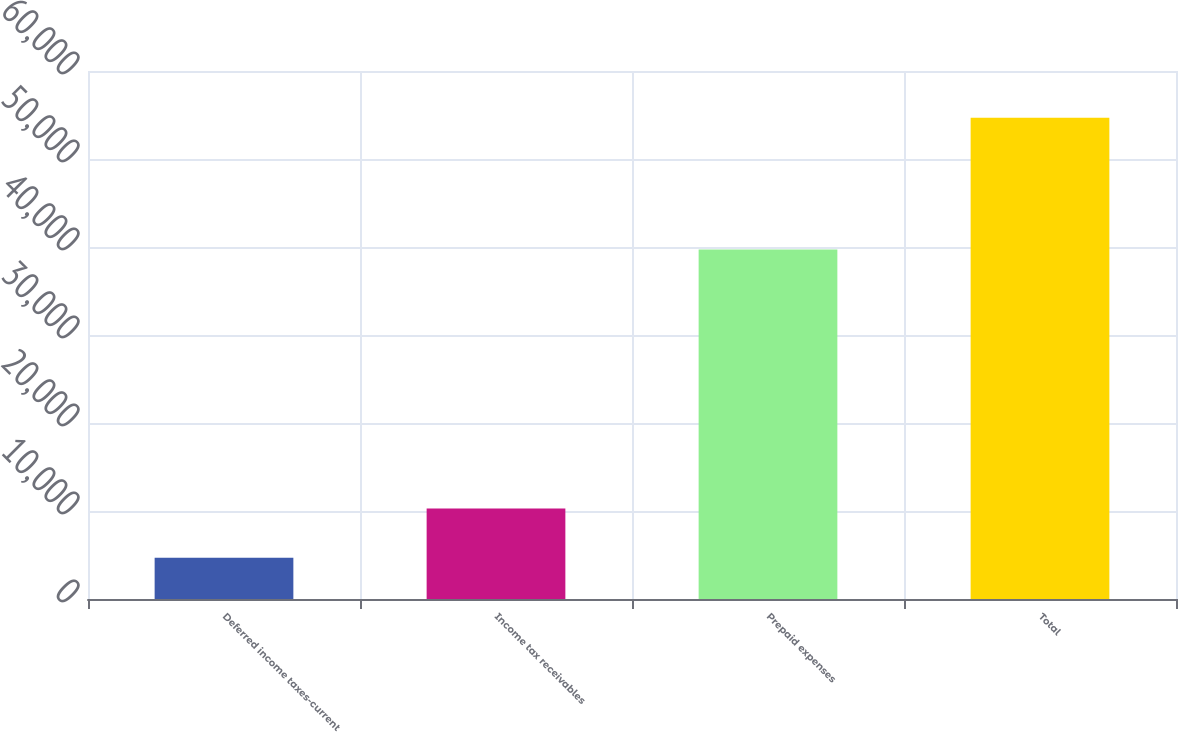Convert chart to OTSL. <chart><loc_0><loc_0><loc_500><loc_500><bar_chart><fcel>Deferred income taxes-current<fcel>Income tax receivables<fcel>Prepaid expenses<fcel>Total<nl><fcel>4689<fcel>10274<fcel>39715<fcel>54678<nl></chart> 